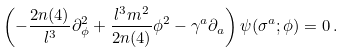<formula> <loc_0><loc_0><loc_500><loc_500>\left ( - \frac { 2 n ( 4 ) } { l ^ { 3 } } \partial _ { \phi } ^ { 2 } + \frac { l ^ { 3 } m ^ { 2 } } { 2 n ( 4 ) } \phi ^ { 2 } - \gamma ^ { a } \partial _ { a } \right ) \psi ( \sigma ^ { a } ; \phi ) = 0 \, .</formula> 